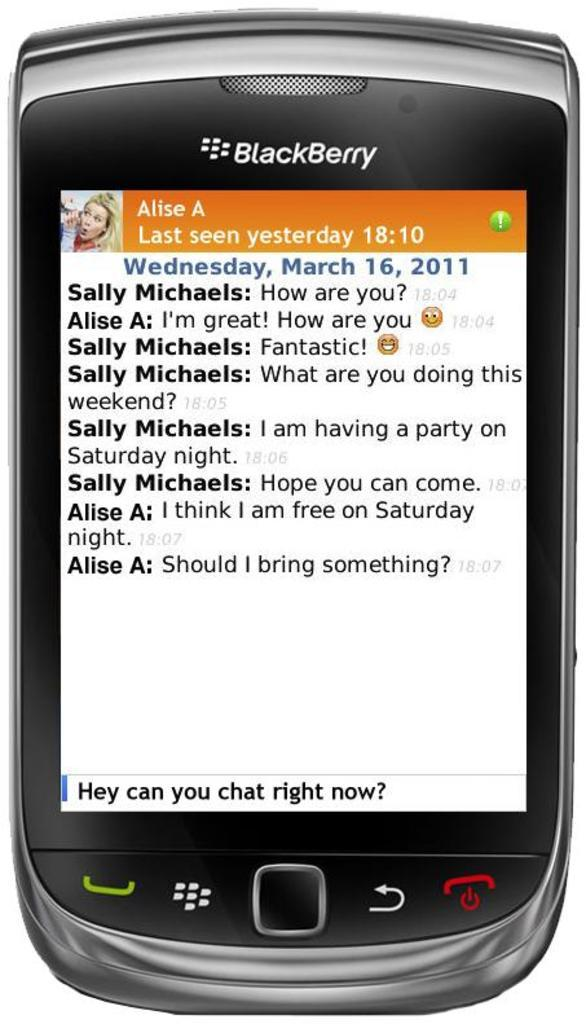<image>
Render a clear and concise summary of the photo. A Blackberry phone displays a conversation between two people. 